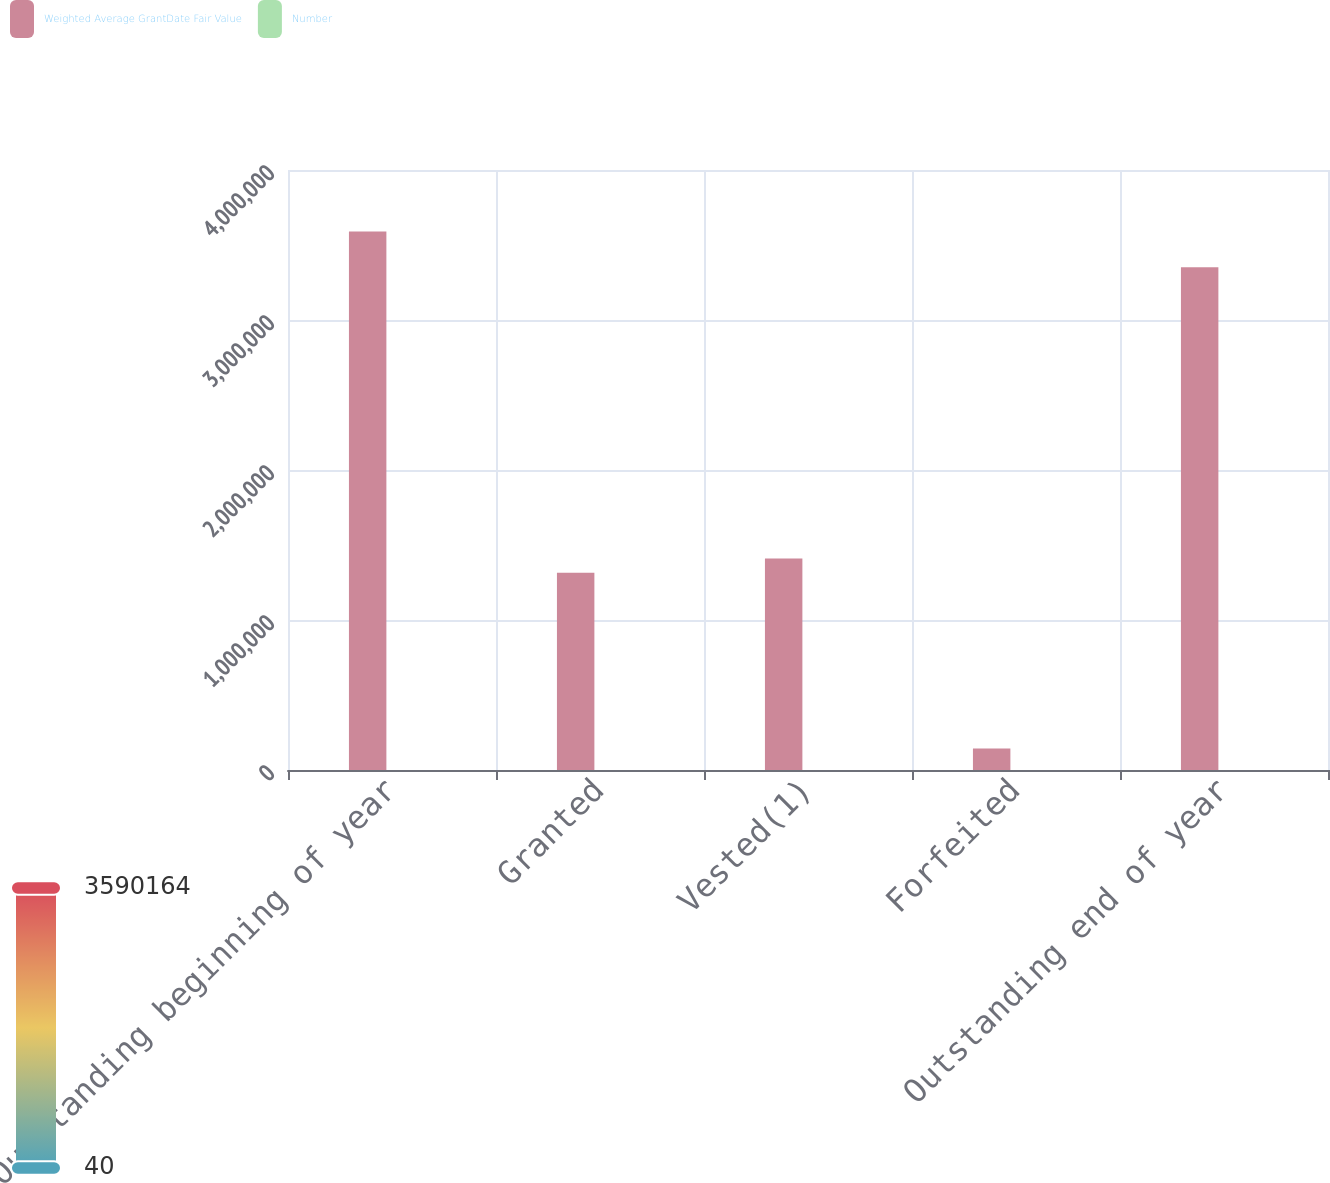Convert chart to OTSL. <chart><loc_0><loc_0><loc_500><loc_500><stacked_bar_chart><ecel><fcel>Outstanding beginning of year<fcel>Granted<fcel>Vested(1)<fcel>Forfeited<fcel>Outstanding end of year<nl><fcel>Weighted Average GrantDate Fair Value<fcel>3.59016e+06<fcel>1.31511e+06<fcel>1.41076e+06<fcel>143552<fcel>3.35095e+06<nl><fcel>Number<fcel>44.45<fcel>47.2<fcel>39.94<fcel>46.72<fcel>47.33<nl></chart> 